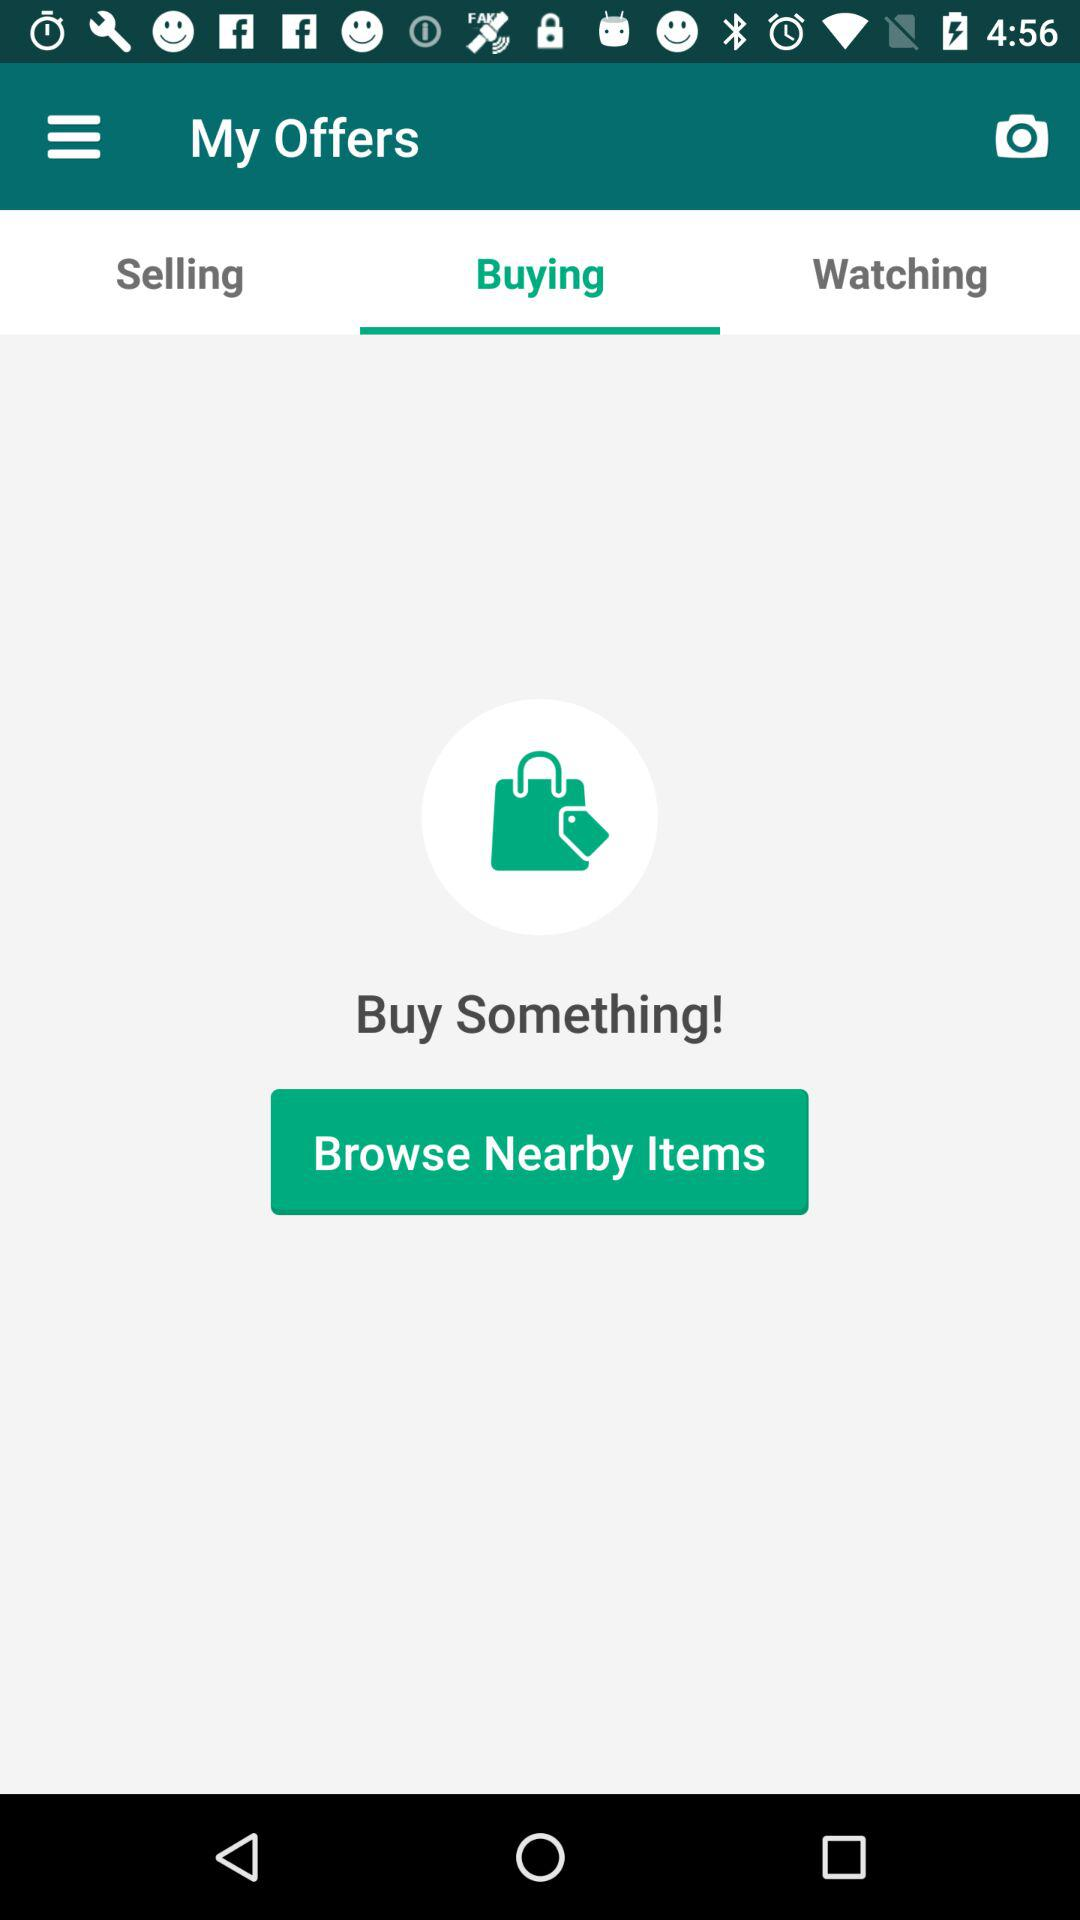Which offers are being watched?
When the provided information is insufficient, respond with <no answer>. <no answer> 